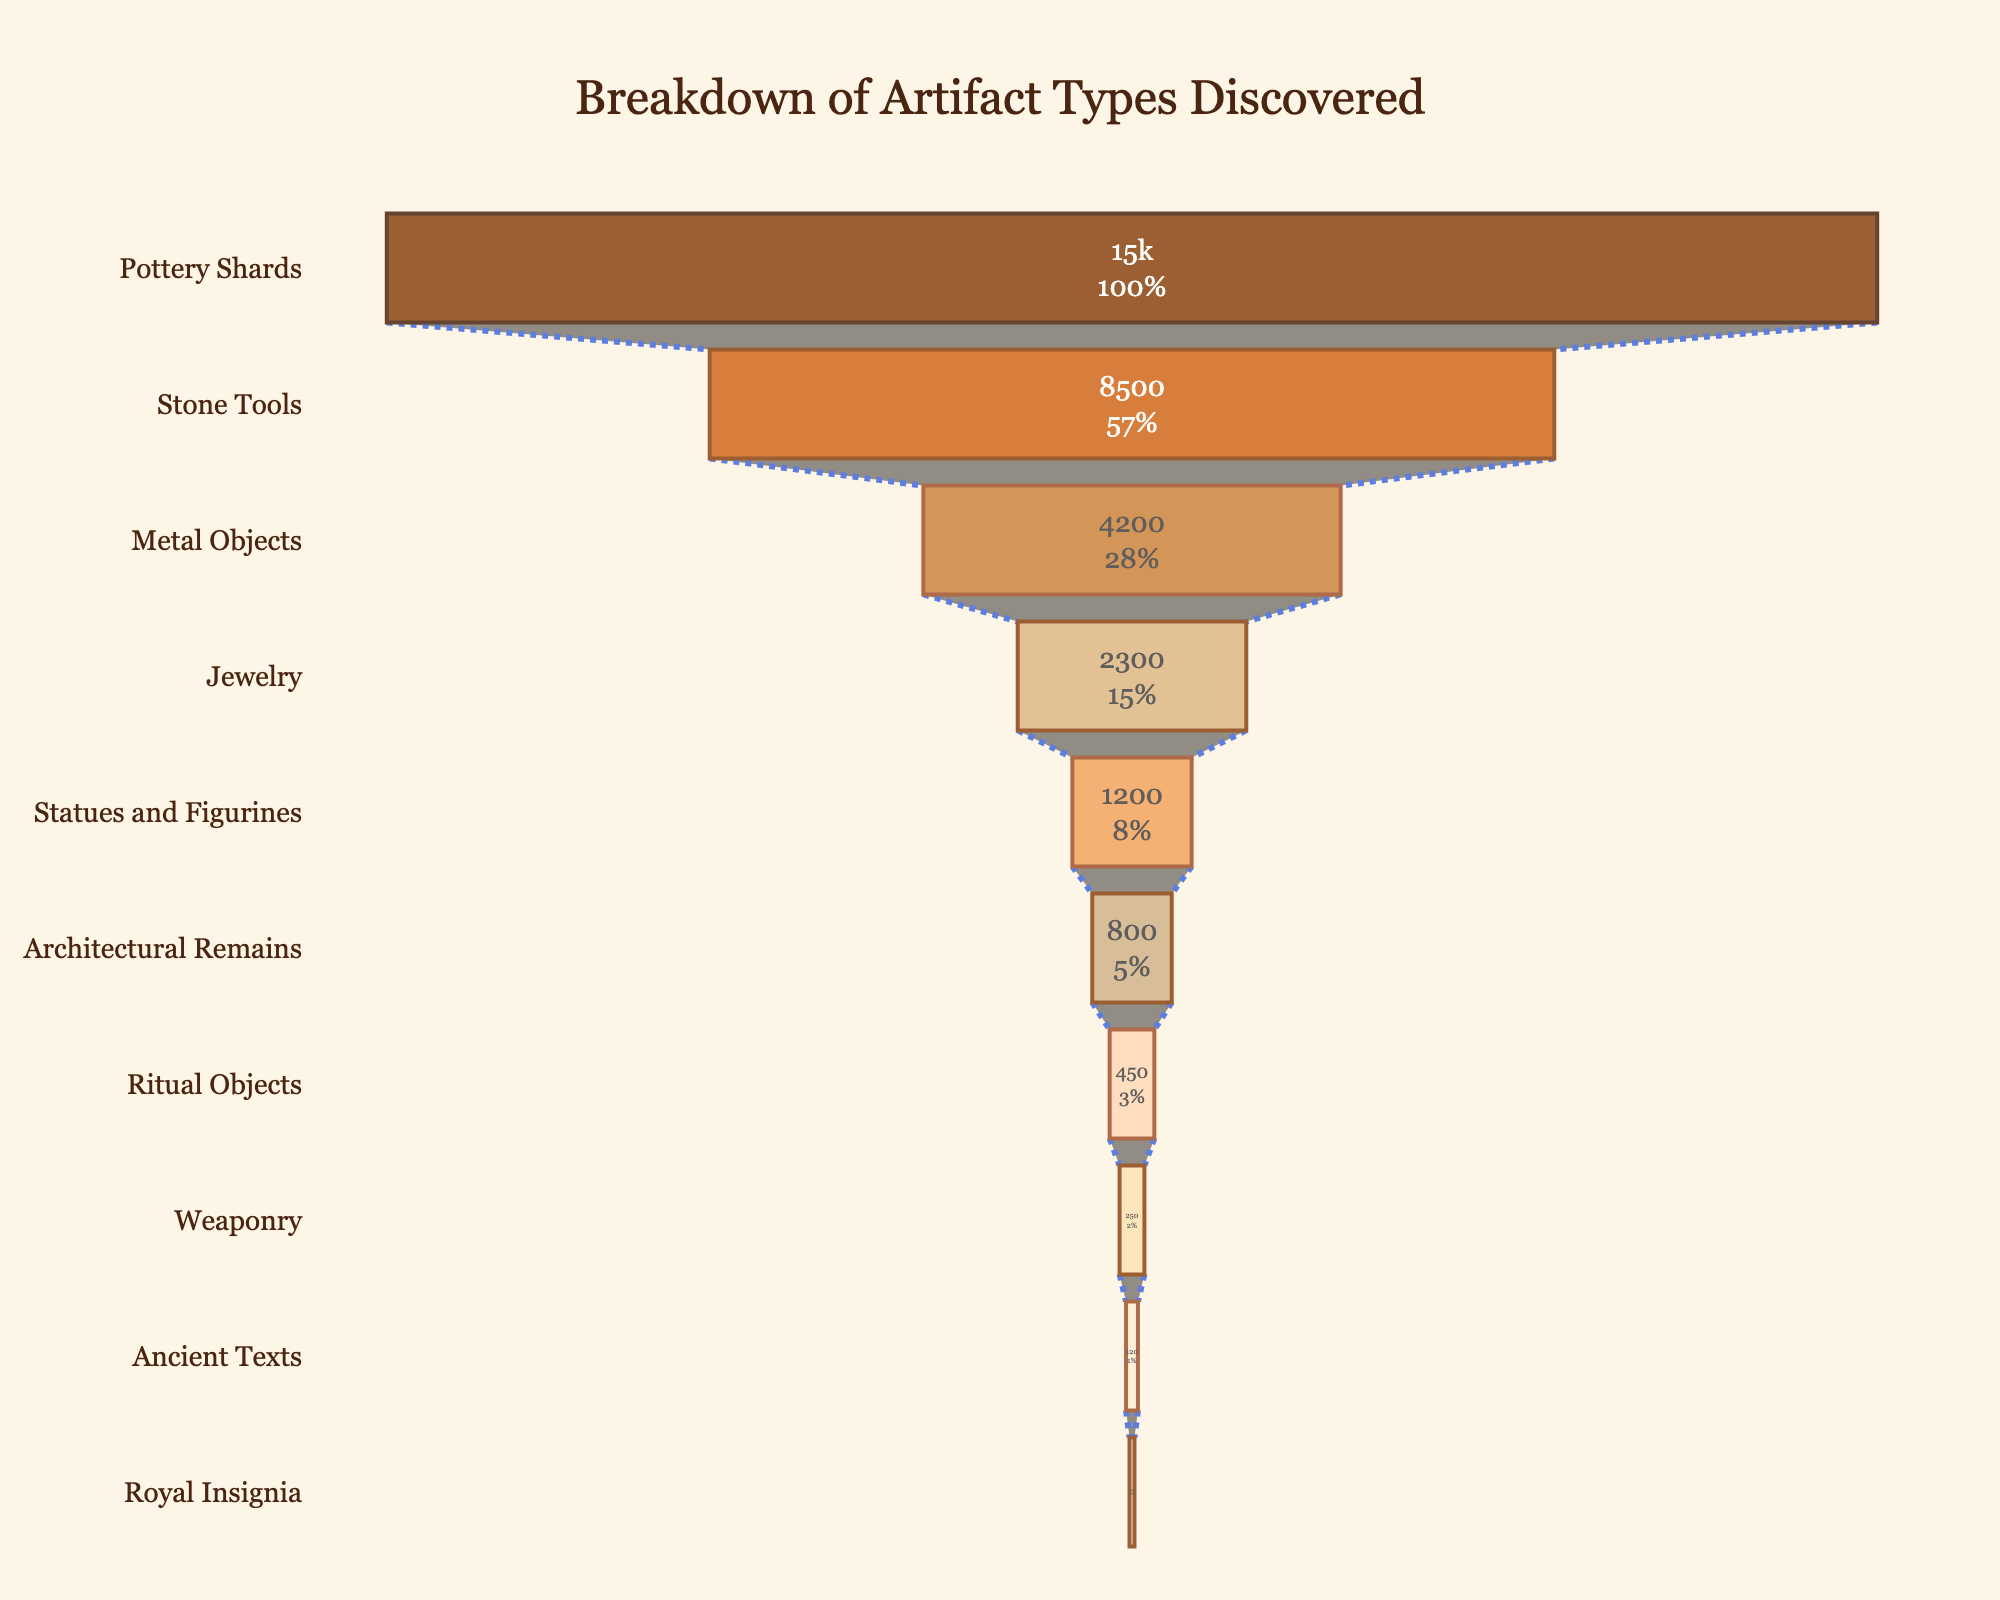Which artifact type is the most common? The artifact type with the highest quantity at the top of the funnel chart is "Pottery Shards" with a count of 15,000.
Answer: Pottery Shards How many metal objects were discovered? The funnel chart shows the quantity for each artifact type. The quantity for "Metal Objects" is 4,200.
Answer: 4,200 What title is given to the funnel chart? The title of the chart is displayed at the top and reads "Breakdown of Artifact Types Discovered".
Answer: Breakdown of Artifact Types Discovered Compare the quantities of stone tools and statues and figurines. The quantities of "Stone Tools" and "Statues and Figurines" can be directly compared from the chart. "Stone Tools" have 8,500, whereas "Statues and Figurines" have 1,200.
Answer: Stone Tools (8,500) vs. Statues and Figurines (1,200) What percentage of the total initial artifacts does jewelry represent? The chart uses text info to display the percentage of each artifact type relative to the initial total. "Jewelry" represents its percentage amongst the total, but for this exact percentage, viewing the precise percentage label would be necessary.
Answer: (from the chart's label) How many total artifacts were discovered in this career? Summing up all quantities from the chart: 15,000 (Pottery Shards) + 8,500 (Stone Tools) + 4,200 (Metal Objects) + 2,300 (Jewelry) + 1,200 (Statues and Figurines) + 800 (Architectural Remains) + 450 (Ritual Objects) + 250 (Weaponry) + 120 (Ancient Texts) + 50 (Royal Insignia) = 32,870.
Answer: 32,870 Which artifact type is less common, ritual objects or weaponry? By comparing "Ritual Objects" and "Weaponry" quantities, "Weaponry" has a smaller count at 250 compared to "Ritual Objects" at 450.
Answer: Weaponry What is the difference in quantity between the least common and the second least common artifact types? The least common is "Royal Insignia" with 50, and the second least common is "Ancient Texts" with 120. The difference is 120 - 50 = 70.
Answer: 70 Explain which artifact type sits exactly at the midpoint of the funnel chart. Assuming a sorted funnel, the artifact at the fifth position from either end of a list of 10 items. Counting from the top, "Statues and Figurines" lies at the midpoint.
Answer: Statues and Figurines What is the combined total of Jewelry, Ritual Objects, and Ancient Texts? Summing the quantities of Jewelry (2,300), Ritual Objects (450), and Ancient Texts (120): 2,300 + 450 + 120 = 2,870.
Answer: 2,870 